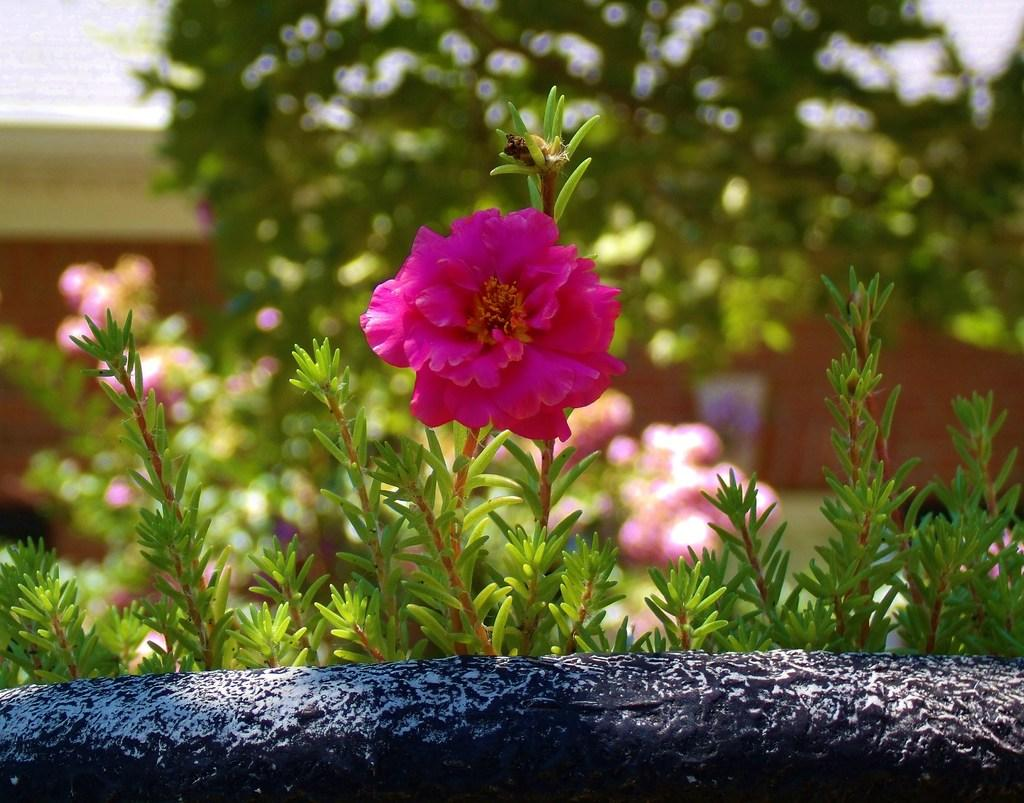What type of flower is present in the image? There is a red color flower with leaves in the image. What can be seen in the background of the image? There are trees in the background of the image. Is there any indication of a building in the background? The transcript does not explicitly confirm the presence of a building in the background, but it is mentioned as a possibility. How many people are enjoying their vacation in the image? There is no indication of people or a vacation in the image; it features a red color flower with leaves and trees in the background. Can you see any chickens in the image? There are no chickens present in the image. 